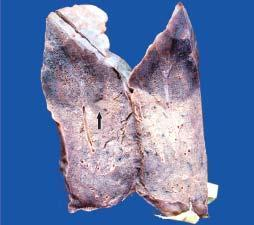does the sectioned surface show dark tan firm areas with base on the pleura?
Answer the question using a single word or phrase. Yes 